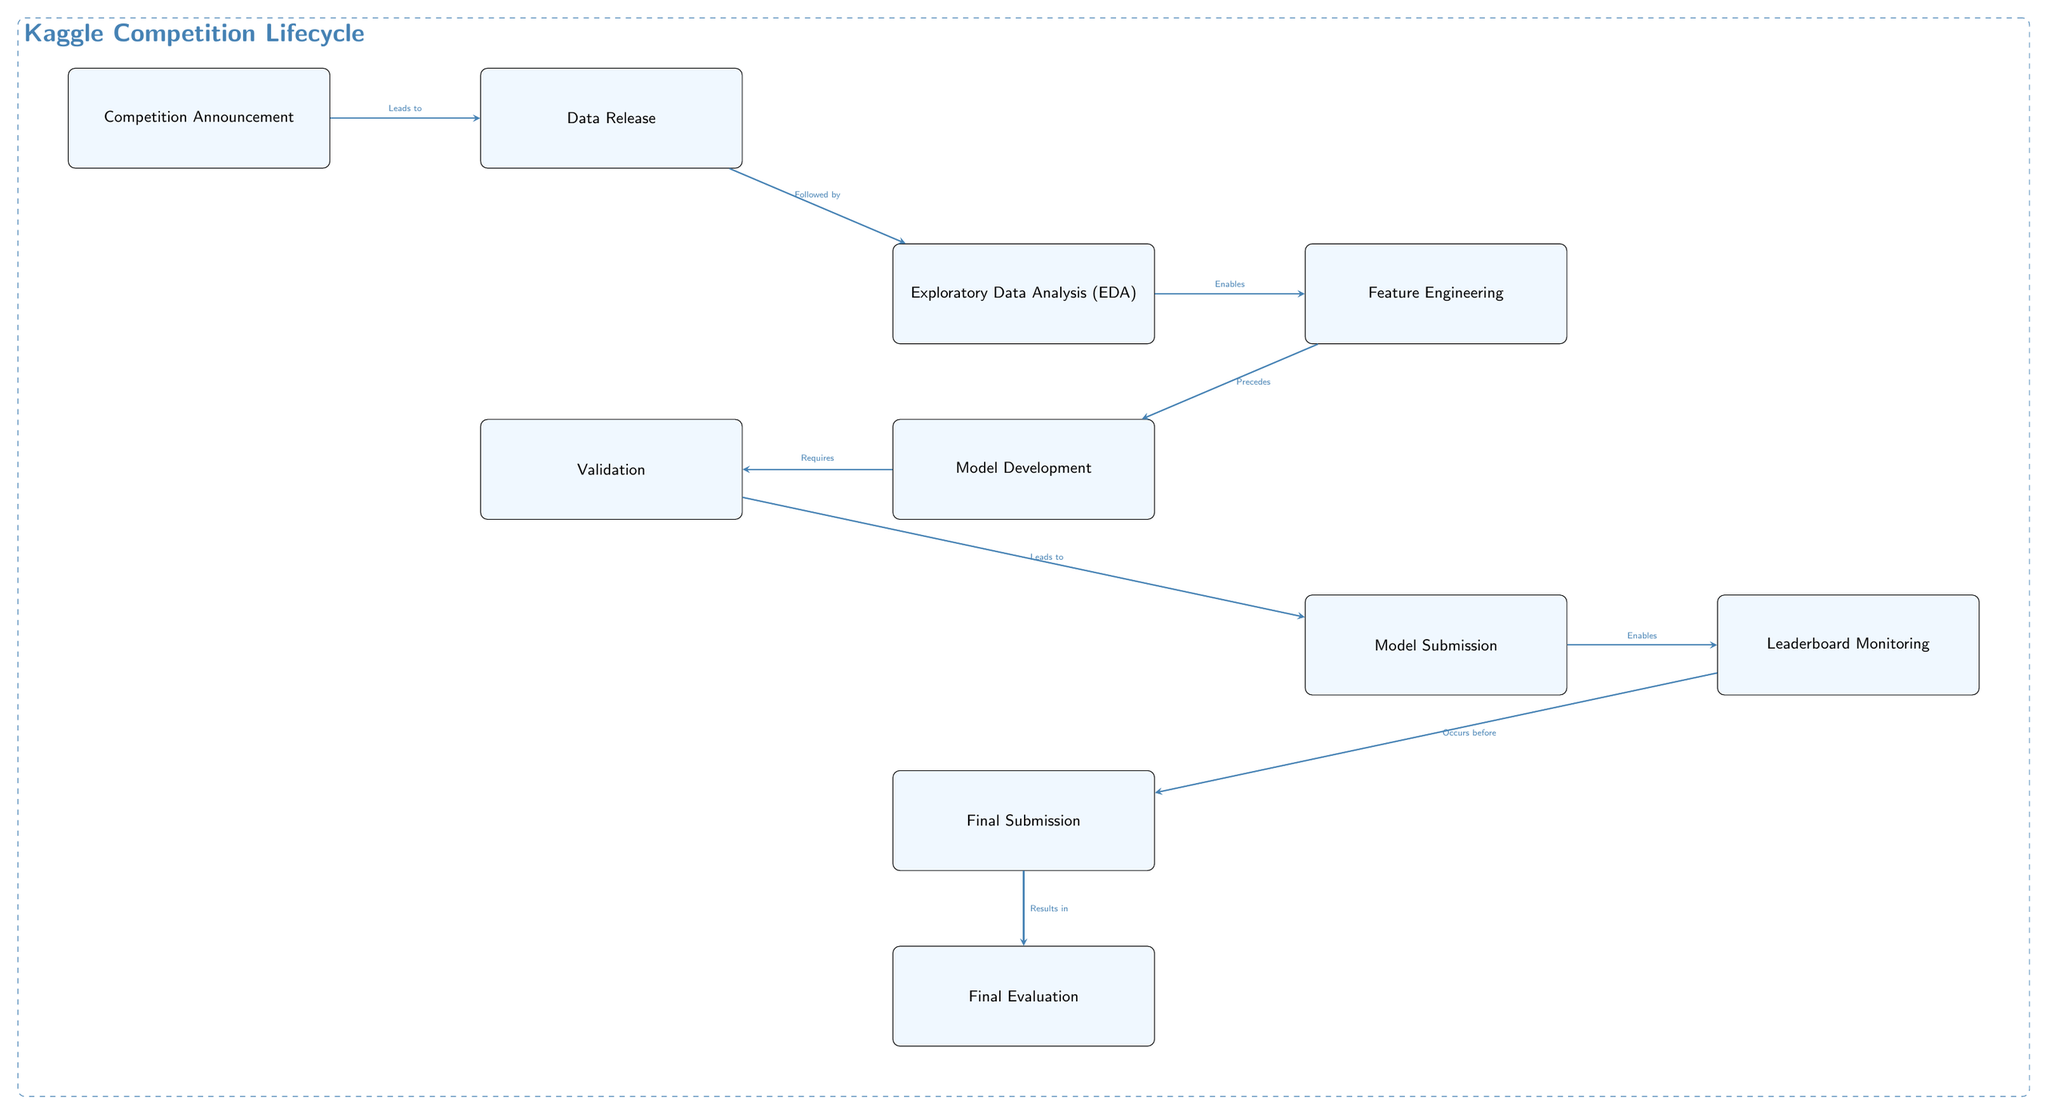What is the first milestone in the diagram? The diagram lists "Competition Announcement" as the starting point or first milestone, labeled clearly at the top left corner.
Answer: Competition Announcement How many main activities are outlined in the timeline? There are ten nodes representing main activities throughout the competition's lifecycle, from the announcement to final evaluation, all clearly depicted in the diagram.
Answer: 10 What step follows the "Data Release"? The next step indicated in the diagram directly after "Data Release" is "Exploratory Data Analysis (EDA)," connected with an arrow to show the flow.
Answer: Exploratory Data Analysis (EDA) Which activity directly precedes "Model Submission"? "Validation" is the step that comes immediately before "Model Submission," demonstrated in the diagram with an arrow connecting them.
Answer: Validation What is the final outcome of the competition lifecycle according to the diagram? The diagram states that "Final Evaluation" is the ultimate outcome of the competition lifecycle, positioned at the bottom as the last node.
Answer: Final Evaluation What activity is enabled by "Exploratory Data Analysis (EDA)"? The following node after "Exploratory Data Analysis (EDA)" is "Feature Engineering," which is explicitly marked as enabled by the EDA activity in the diagram.
Answer: Feature Engineering Which two activities are connected with the relationship "Leads to"? The diagram specifies two connections with the label "Leads to": "Competition Announcement" leads to "Data Release," and "Validation" leads to "Model Submission."
Answer: Competition Announcement, Validation How many edges connect "Model Development" with other activities? The "Model Development" step has two connected edges: one leading to "Validation" and the other to "Model Submission," indicating its relationships with these activities.
Answer: 2 What enables "Feature Engineering"? The diagram indicates that "Exploratory Data Analysis (EDA)" enables "Feature Engineering," marked by the connecting arrow showing this relationship.
Answer: Exploratory Data Analysis (EDA) 